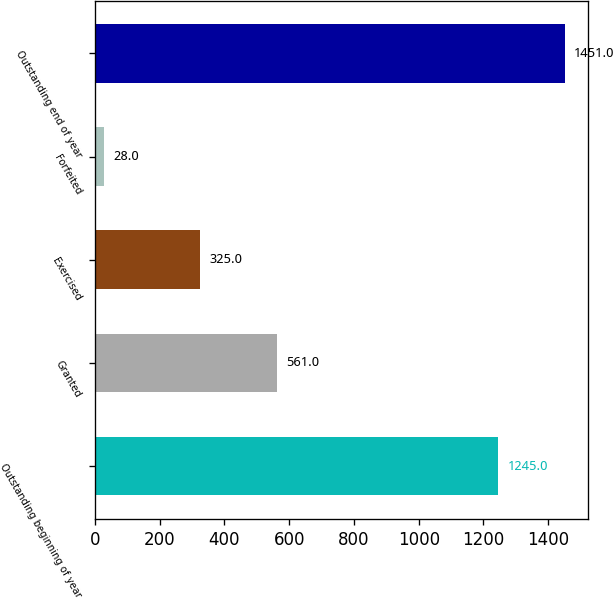<chart> <loc_0><loc_0><loc_500><loc_500><bar_chart><fcel>Outstanding beginning of year<fcel>Granted<fcel>Exercised<fcel>Forfeited<fcel>Outstanding end of year<nl><fcel>1245<fcel>561<fcel>325<fcel>28<fcel>1451<nl></chart> 